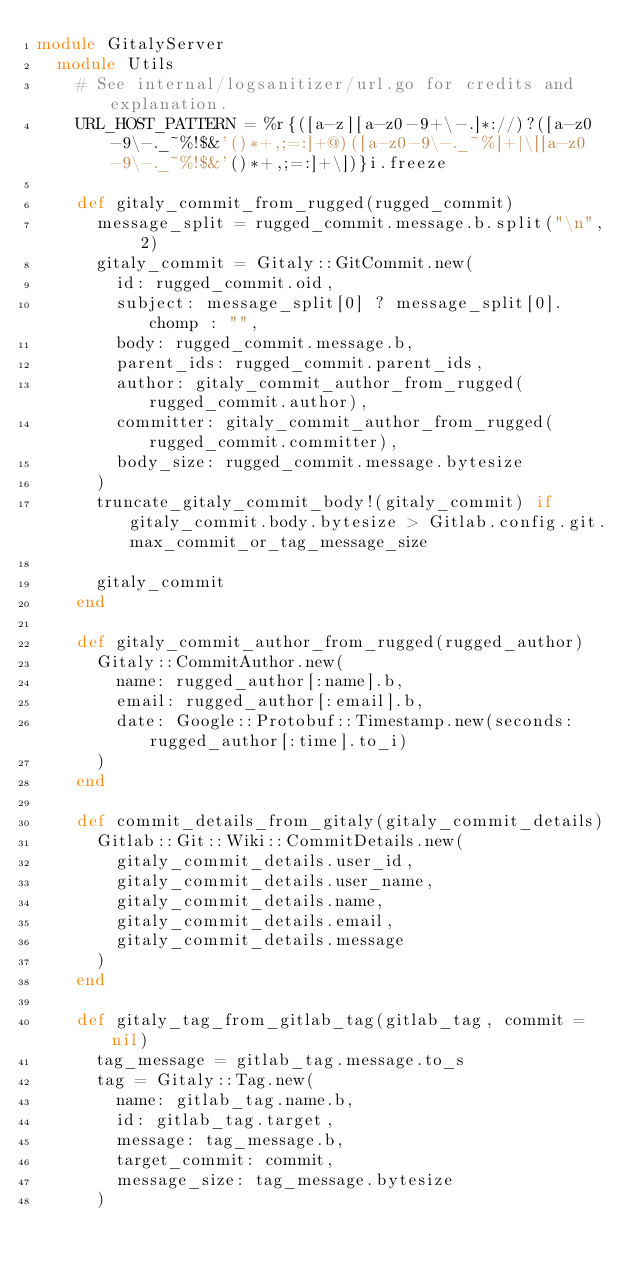<code> <loc_0><loc_0><loc_500><loc_500><_Ruby_>module GitalyServer
  module Utils
    # See internal/logsanitizer/url.go for credits and explanation.
    URL_HOST_PATTERN = %r{([a-z][a-z0-9+\-.]*://)?([a-z0-9\-._~%!$&'()*+,;=:]+@)([a-z0-9\-._~%]+|\[[a-z0-9\-._~%!$&'()*+,;=:]+\])}i.freeze

    def gitaly_commit_from_rugged(rugged_commit)
      message_split = rugged_commit.message.b.split("\n", 2)
      gitaly_commit = Gitaly::GitCommit.new(
        id: rugged_commit.oid,
        subject: message_split[0] ? message_split[0].chomp : "",
        body: rugged_commit.message.b,
        parent_ids: rugged_commit.parent_ids,
        author: gitaly_commit_author_from_rugged(rugged_commit.author),
        committer: gitaly_commit_author_from_rugged(rugged_commit.committer),
        body_size: rugged_commit.message.bytesize
      )
      truncate_gitaly_commit_body!(gitaly_commit) if gitaly_commit.body.bytesize > Gitlab.config.git.max_commit_or_tag_message_size

      gitaly_commit
    end

    def gitaly_commit_author_from_rugged(rugged_author)
      Gitaly::CommitAuthor.new(
        name: rugged_author[:name].b,
        email: rugged_author[:email].b,
        date: Google::Protobuf::Timestamp.new(seconds: rugged_author[:time].to_i)
      )
    end

    def commit_details_from_gitaly(gitaly_commit_details)
      Gitlab::Git::Wiki::CommitDetails.new(
        gitaly_commit_details.user_id,
        gitaly_commit_details.user_name,
        gitaly_commit_details.name,
        gitaly_commit_details.email,
        gitaly_commit_details.message
      )
    end

    def gitaly_tag_from_gitlab_tag(gitlab_tag, commit = nil)
      tag_message = gitlab_tag.message.to_s
      tag = Gitaly::Tag.new(
        name: gitlab_tag.name.b,
        id: gitlab_tag.target,
        message: tag_message.b,
        target_commit: commit,
        message_size: tag_message.bytesize
      )
</code> 